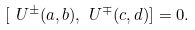<formula> <loc_0><loc_0><loc_500><loc_500>[ \ U ^ { \pm } ( a , b ) , \ U ^ { \mp } ( c , d ) ] = 0 .</formula> 